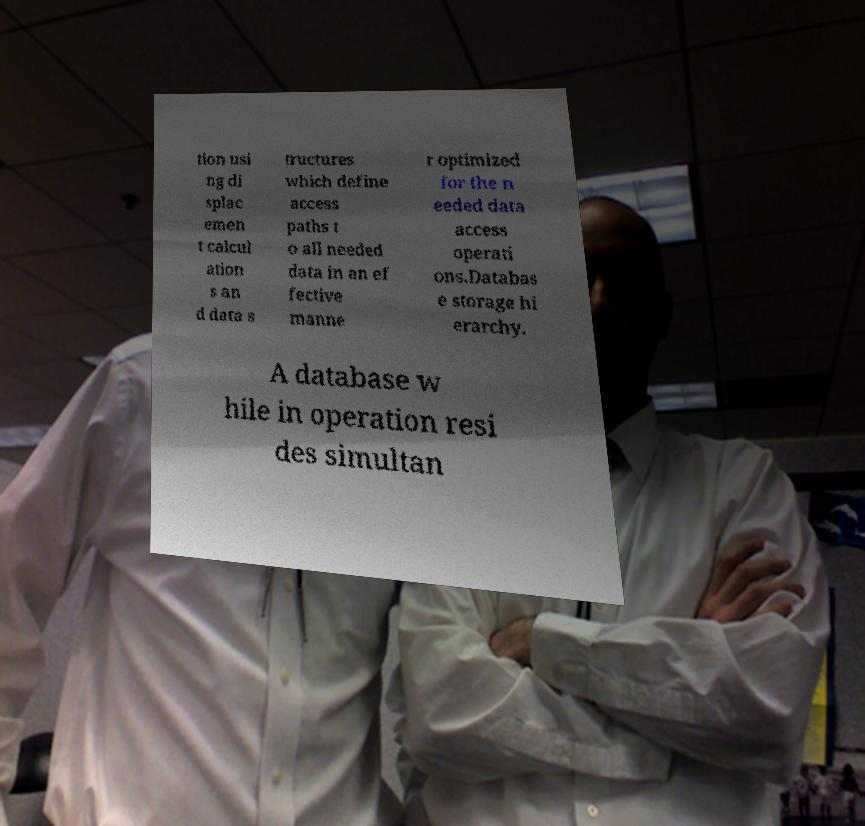For documentation purposes, I need the text within this image transcribed. Could you provide that? tion usi ng di splac emen t calcul ation s an d data s tructures which define access paths t o all needed data in an ef fective manne r optimized for the n eeded data access operati ons.Databas e storage hi erarchy. A database w hile in operation resi des simultan 